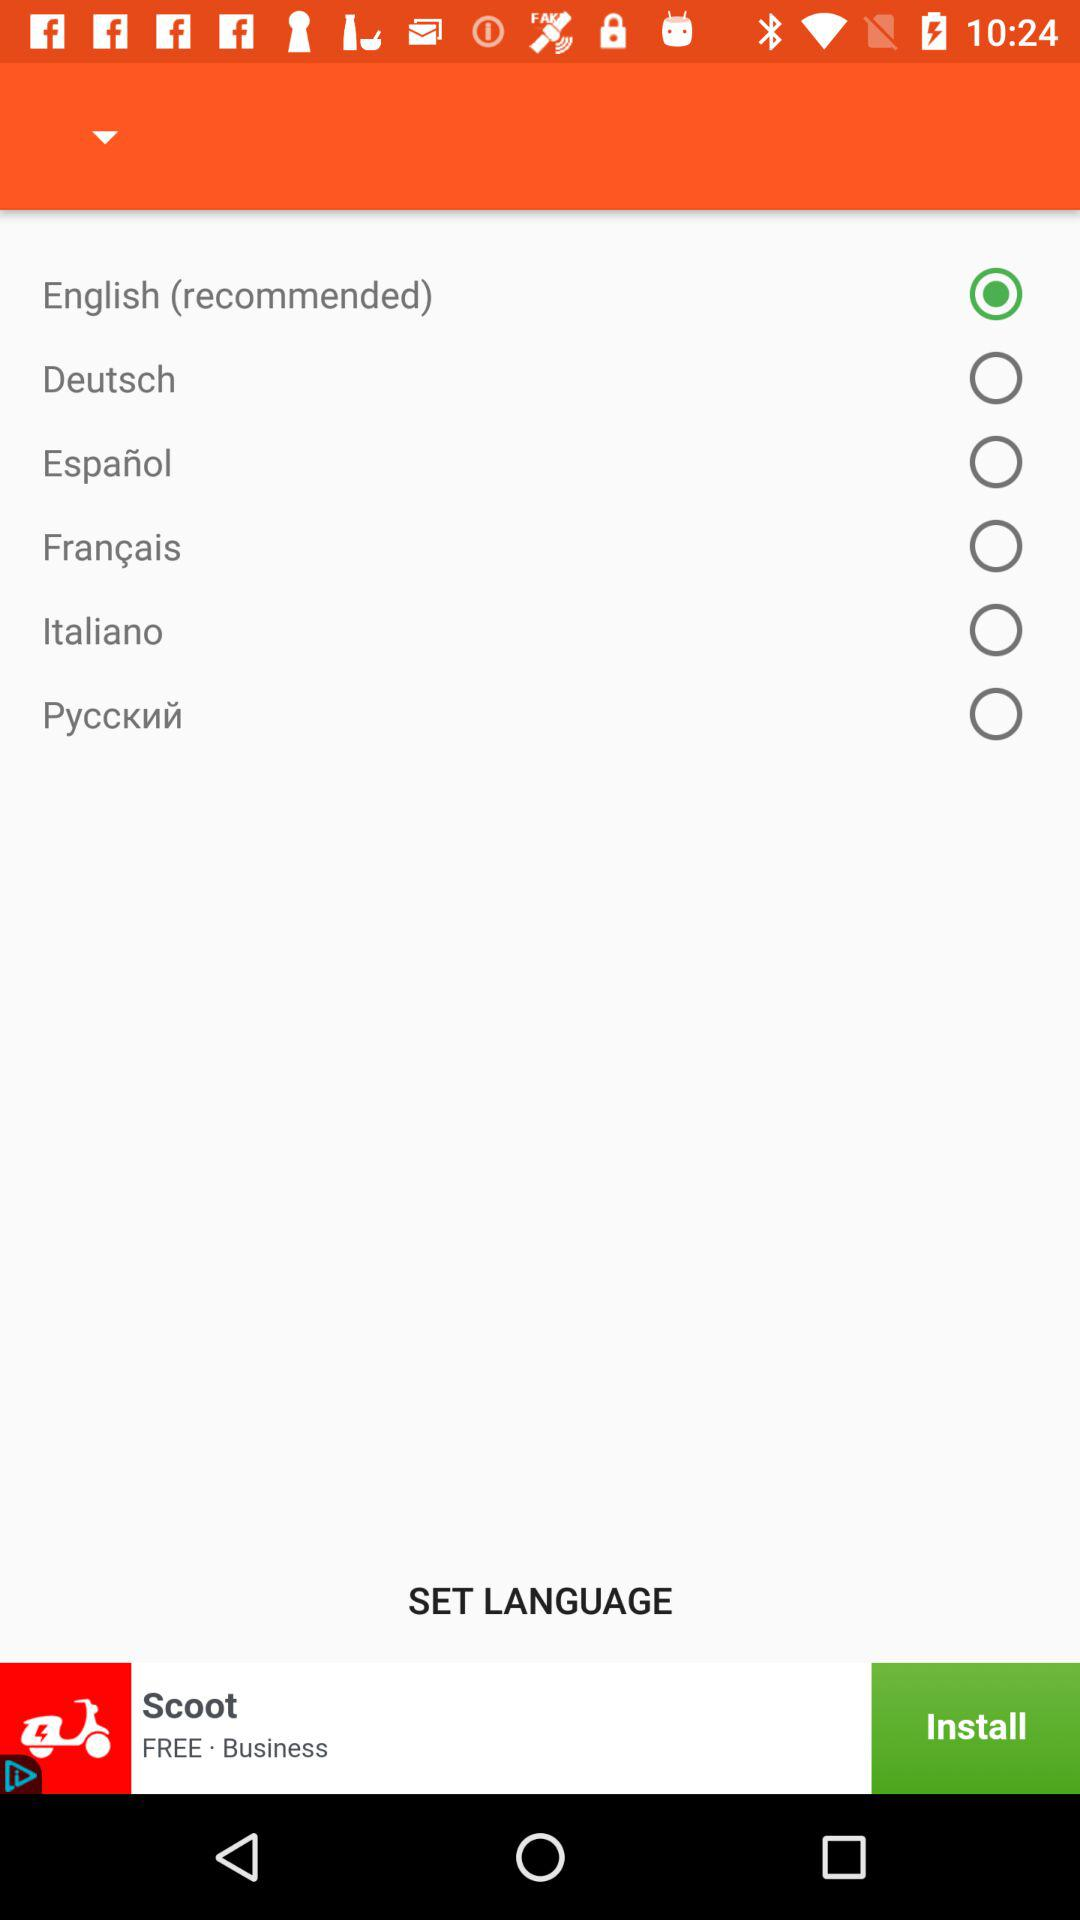How many languages are available to select from?
Answer the question using a single word or phrase. 6 